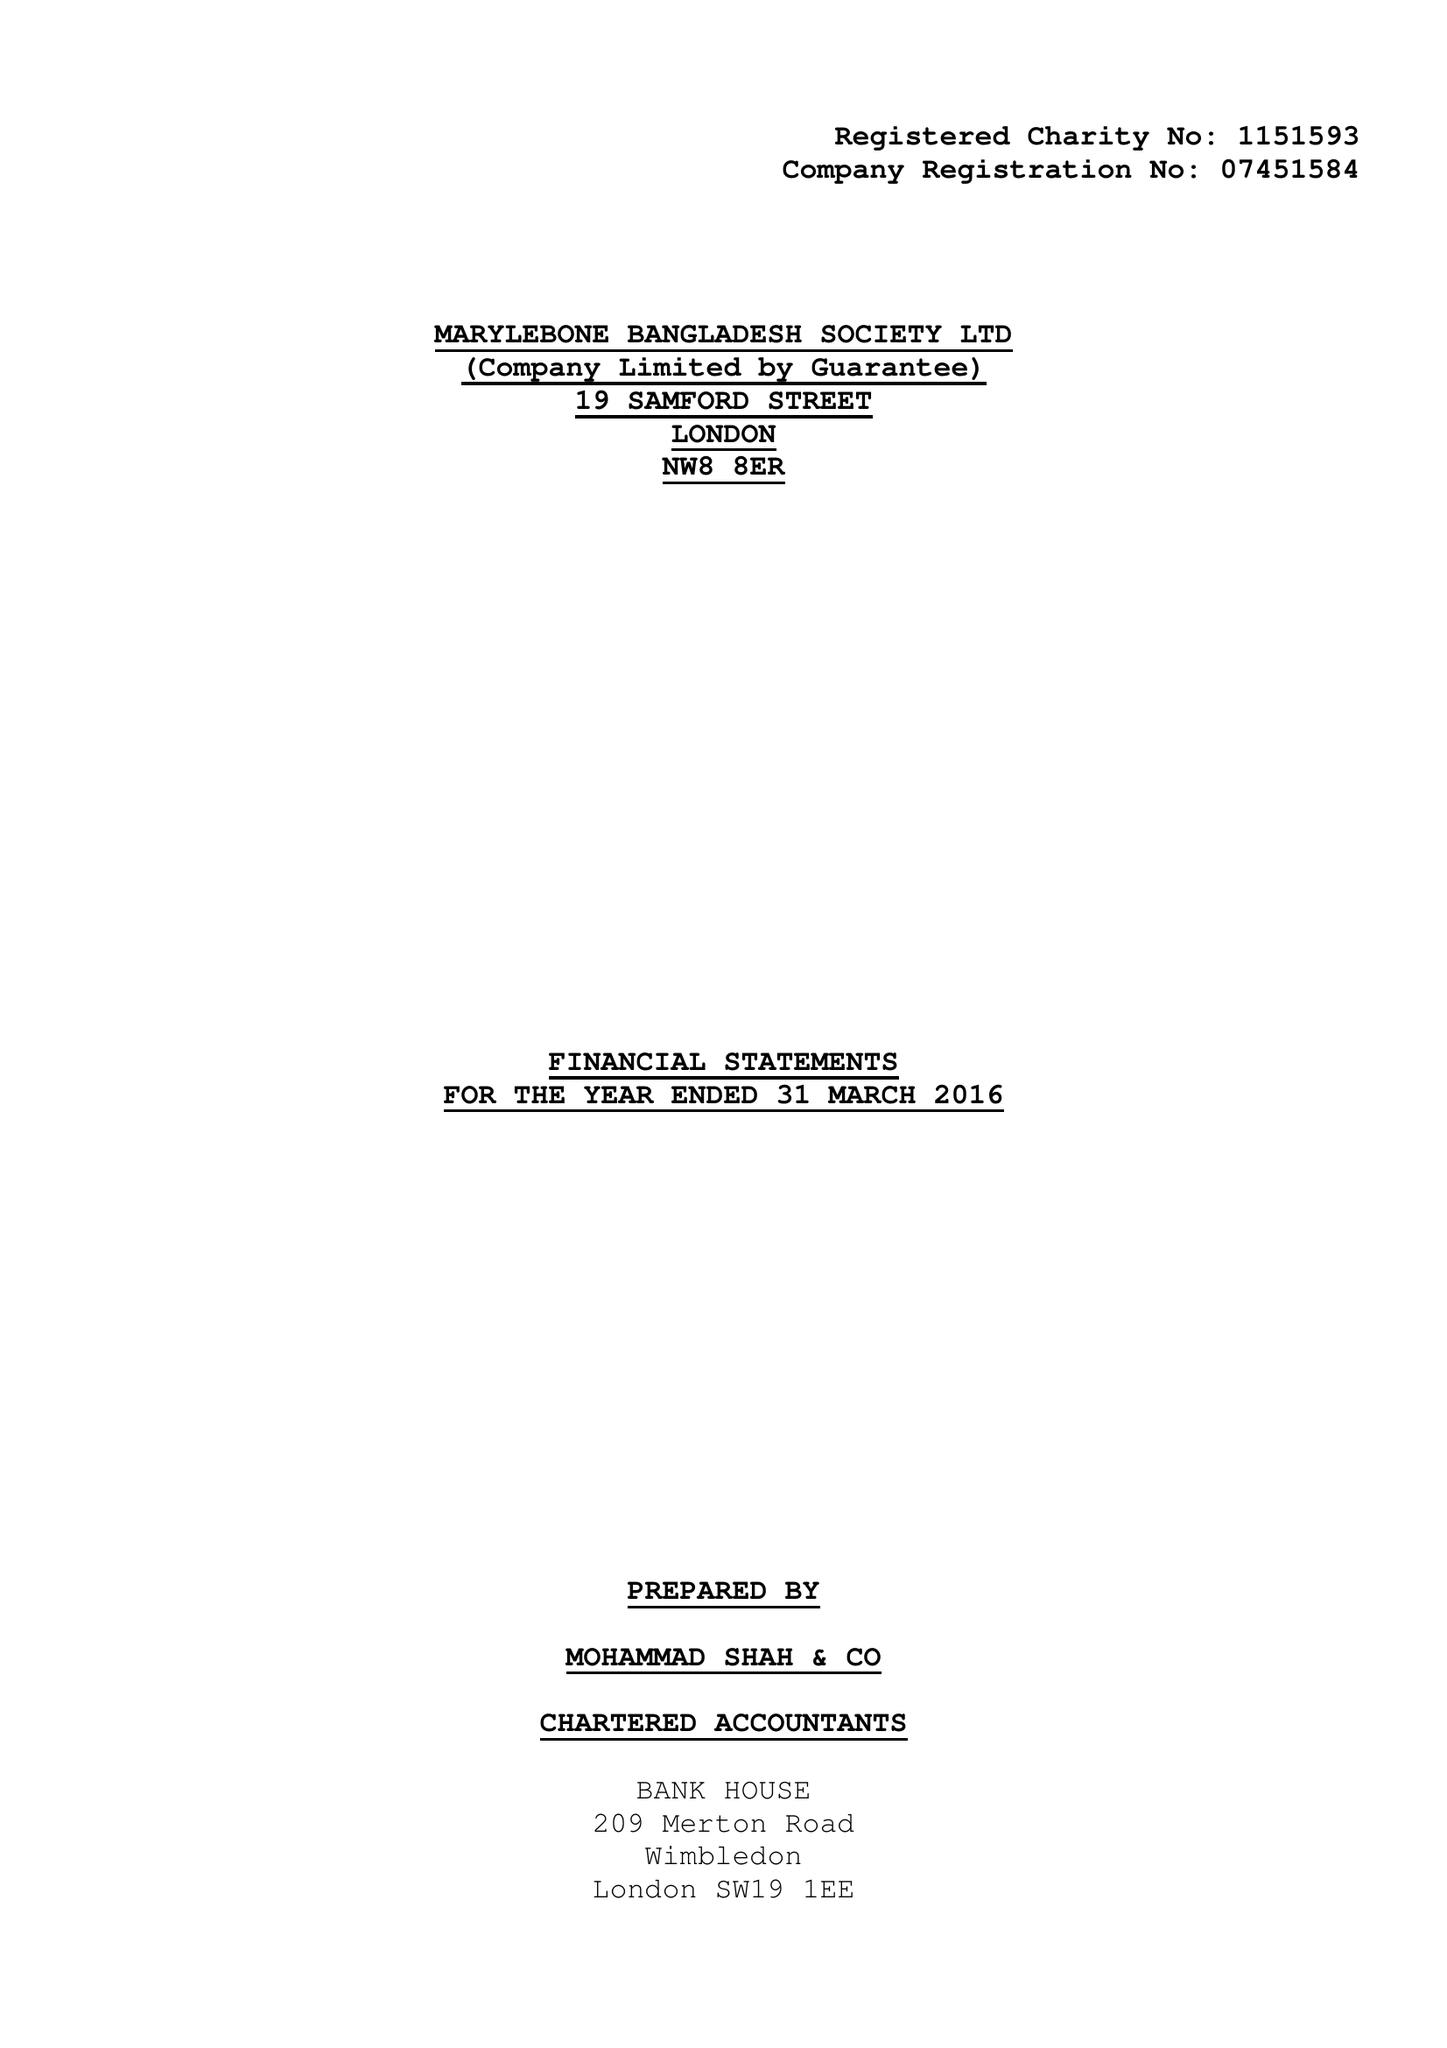What is the value for the address__postcode?
Answer the question using a single word or phrase. NW8 8ER 